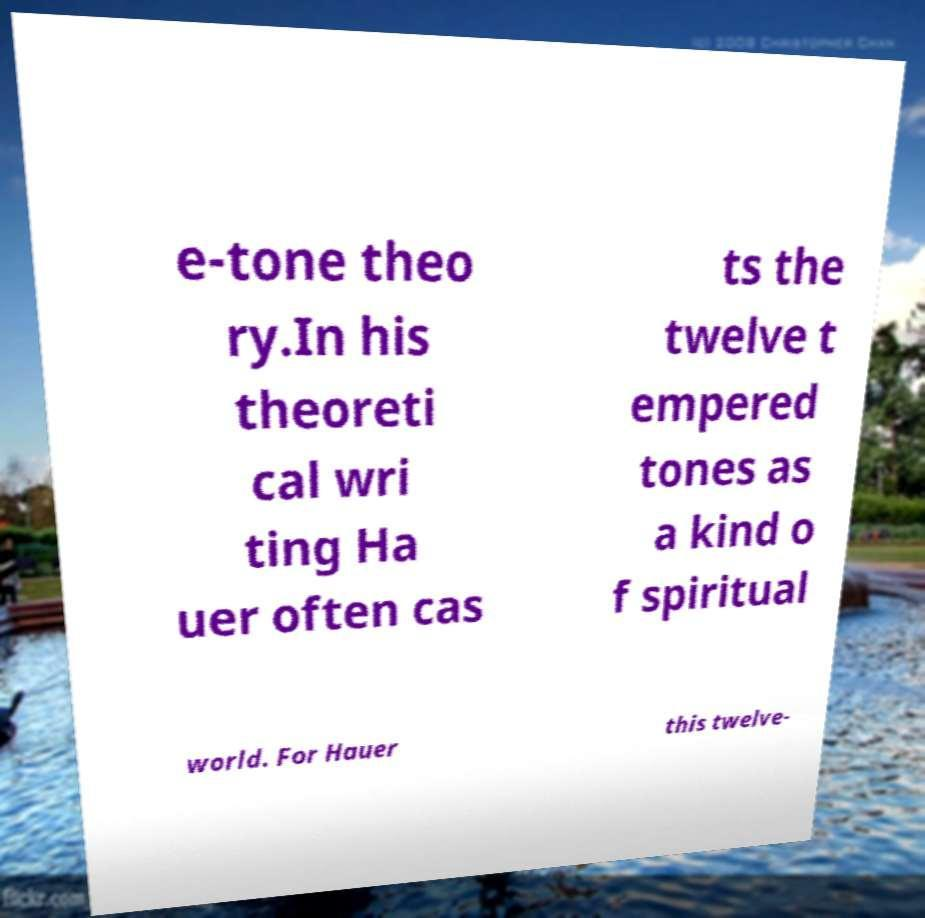Please identify and transcribe the text found in this image. e-tone theo ry.In his theoreti cal wri ting Ha uer often cas ts the twelve t empered tones as a kind o f spiritual world. For Hauer this twelve- 